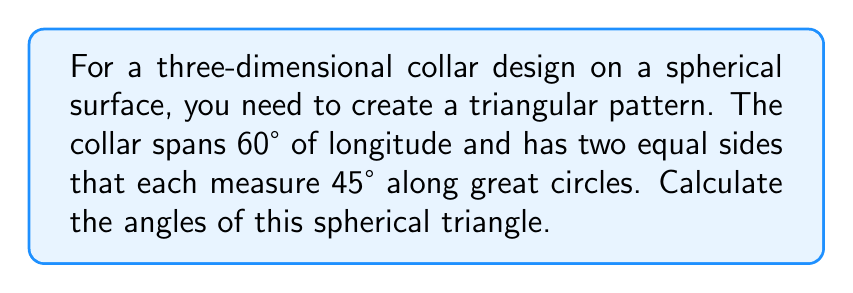Teach me how to tackle this problem. Let's approach this step-by-step using spherical trigonometry:

1) We have a spherical triangle with the following properties:
   - One side (let's call it c) measures 60° (the longitude span)
   - The other two sides (a and b) are equal and measure 45° each

2) In spherical trigonometry, we can use the spherical law of cosines:

   $$\cos(c) = \cos(a)\cos(b) + \sin(a)\sin(b)\cos(C)$$

   Where C is the angle opposite side c.

3) Since a = b = 45° and c = 60°, we can substitute these values:

   $$\cos(60°) = \cos(45°)\cos(45°) + \sin(45°)\sin(45°)\cos(C)$$

4) Simplify:
   $$0.5 = (\frac{\sqrt{2}}{2})^2 + (\frac{\sqrt{2}}{2})^2\cos(C)$$
   $$0.5 = 0.5 + 0.5\cos(C)$$

5) Solve for C:
   $$0 = 0.5\cos(C)$$
   $$\cos(C) = 0$$
   $$C = 90°$$

6) Due to the symmetry of the triangle (two equal sides), the other two angles (A and B) must be equal. Let's call this angle X.

7) In a spherical triangle, the sum of angles is always greater than 180°. The excess is given by the formula:

   $$A + B + C - 180° = \text{area of triangle in steradians}$$

8) Given the symmetry, we can write:

   $$2X + 90° - 180° = \text{area}$$

9) The area of a spherical triangle is given by:

   $$\text{area} = R^2(a + b + c - \pi)$$ (in steradians, where R is the radius)

   In our case: $$\text{area} = (45° + 45° + 60° - 180°) \cdot \frac{\pi}{180°} = \frac{\pi}{6}$$ steradians

10) Substituting back:

    $$2X + 90° - 180° = \frac{\pi}{6}$$
    $$2X = 90° + \frac{\pi}{6} \cdot \frac{180°}{\pi} = 120°$$
    $$X = 60°$$

Therefore, the angles of the spherical triangle are 90°, 60°, and 60°.
Answer: 90°, 60°, 60° 